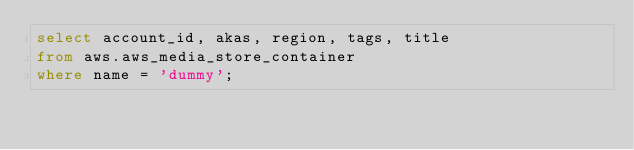<code> <loc_0><loc_0><loc_500><loc_500><_SQL_>select account_id, akas, region, tags, title
from aws.aws_media_store_container
where name = 'dummy';
 </code> 